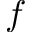Convert formula to latex. <formula><loc_0><loc_0><loc_500><loc_500>f</formula> 